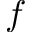Convert formula to latex. <formula><loc_0><loc_0><loc_500><loc_500>f</formula> 